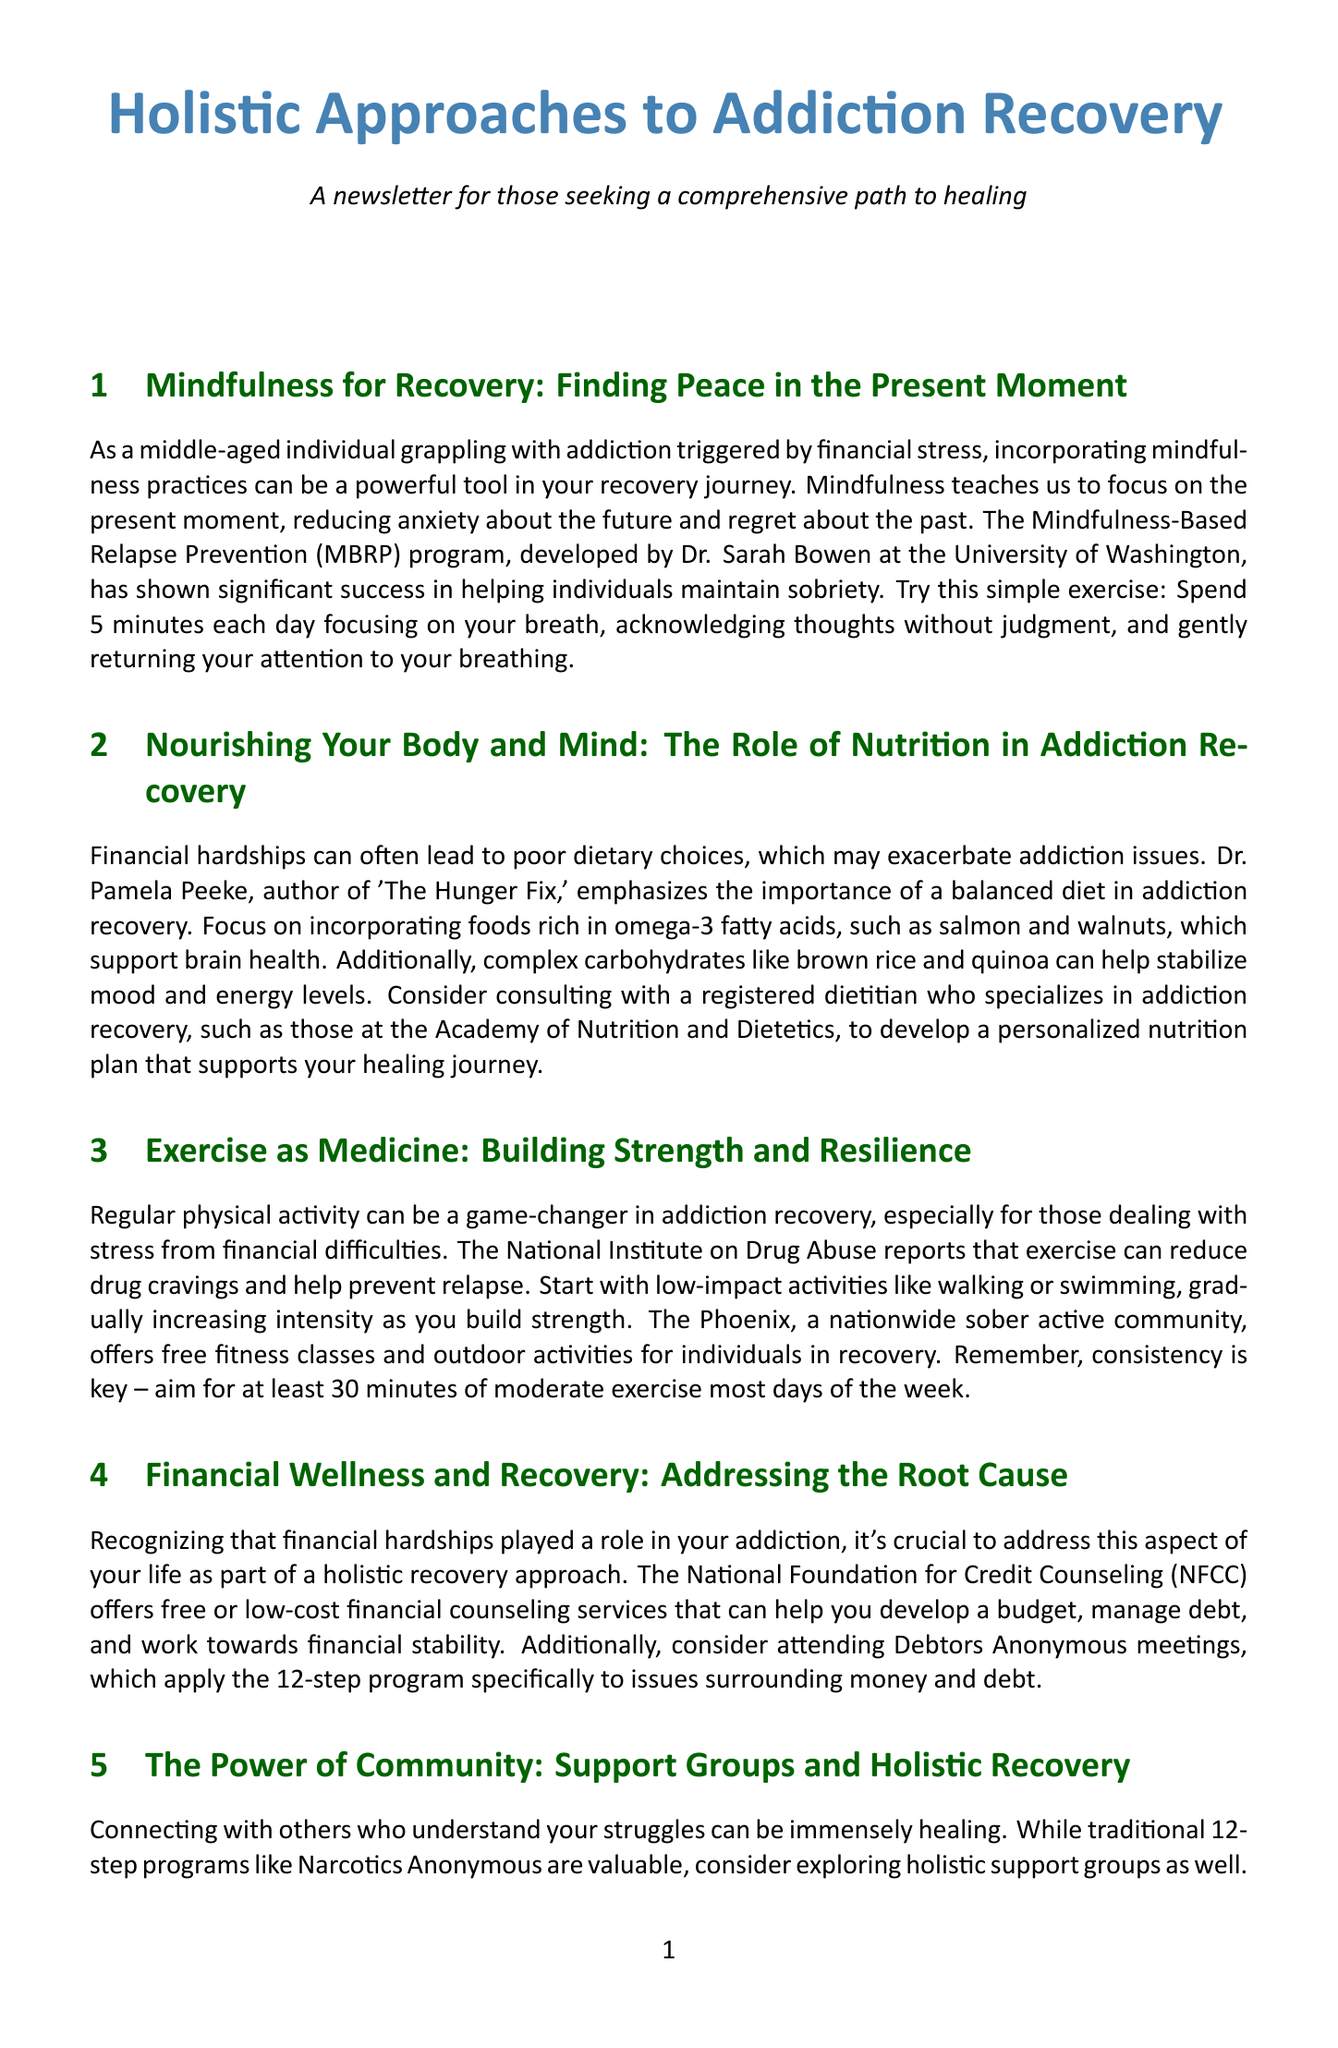what is the title of the mindfulness section? The title is explicitly stated at the beginning of that section.
Answer: Mindfulness for Recovery: Finding Peace in the Present Moment who developed the MBRP program? The document mentions the creator of the MBRP program and their affiliation.
Answer: Dr. Sarah Bowen what is the recommended exercise duration per day? The newsletter advises a specific duration for exercise activities.
Answer: 30 minutes which author emphasizes the role of nutrition in addiction recovery? The document identifies this author's significance in the context of nutrition.
Answer: Dr. Pamela Peeke what type of community does The Phoenix offer? The content specifies the nature of activities organized by The Phoenix.
Answer: Sober active community what dietary component supports brain health according to the newsletter? The document mentions specific food items that contribute to health.
Answer: Omega-3 fatty acids which organization offers free or low-cost financial counseling? The newsletter presents an organization that provides assistance for financial issues.
Answer: National Foundation for Credit Counseling what approach does SMART Recovery incorporate? The document describes a specific methodology used in SMART Recovery.
Answer: Cognitive-behavioral techniques 